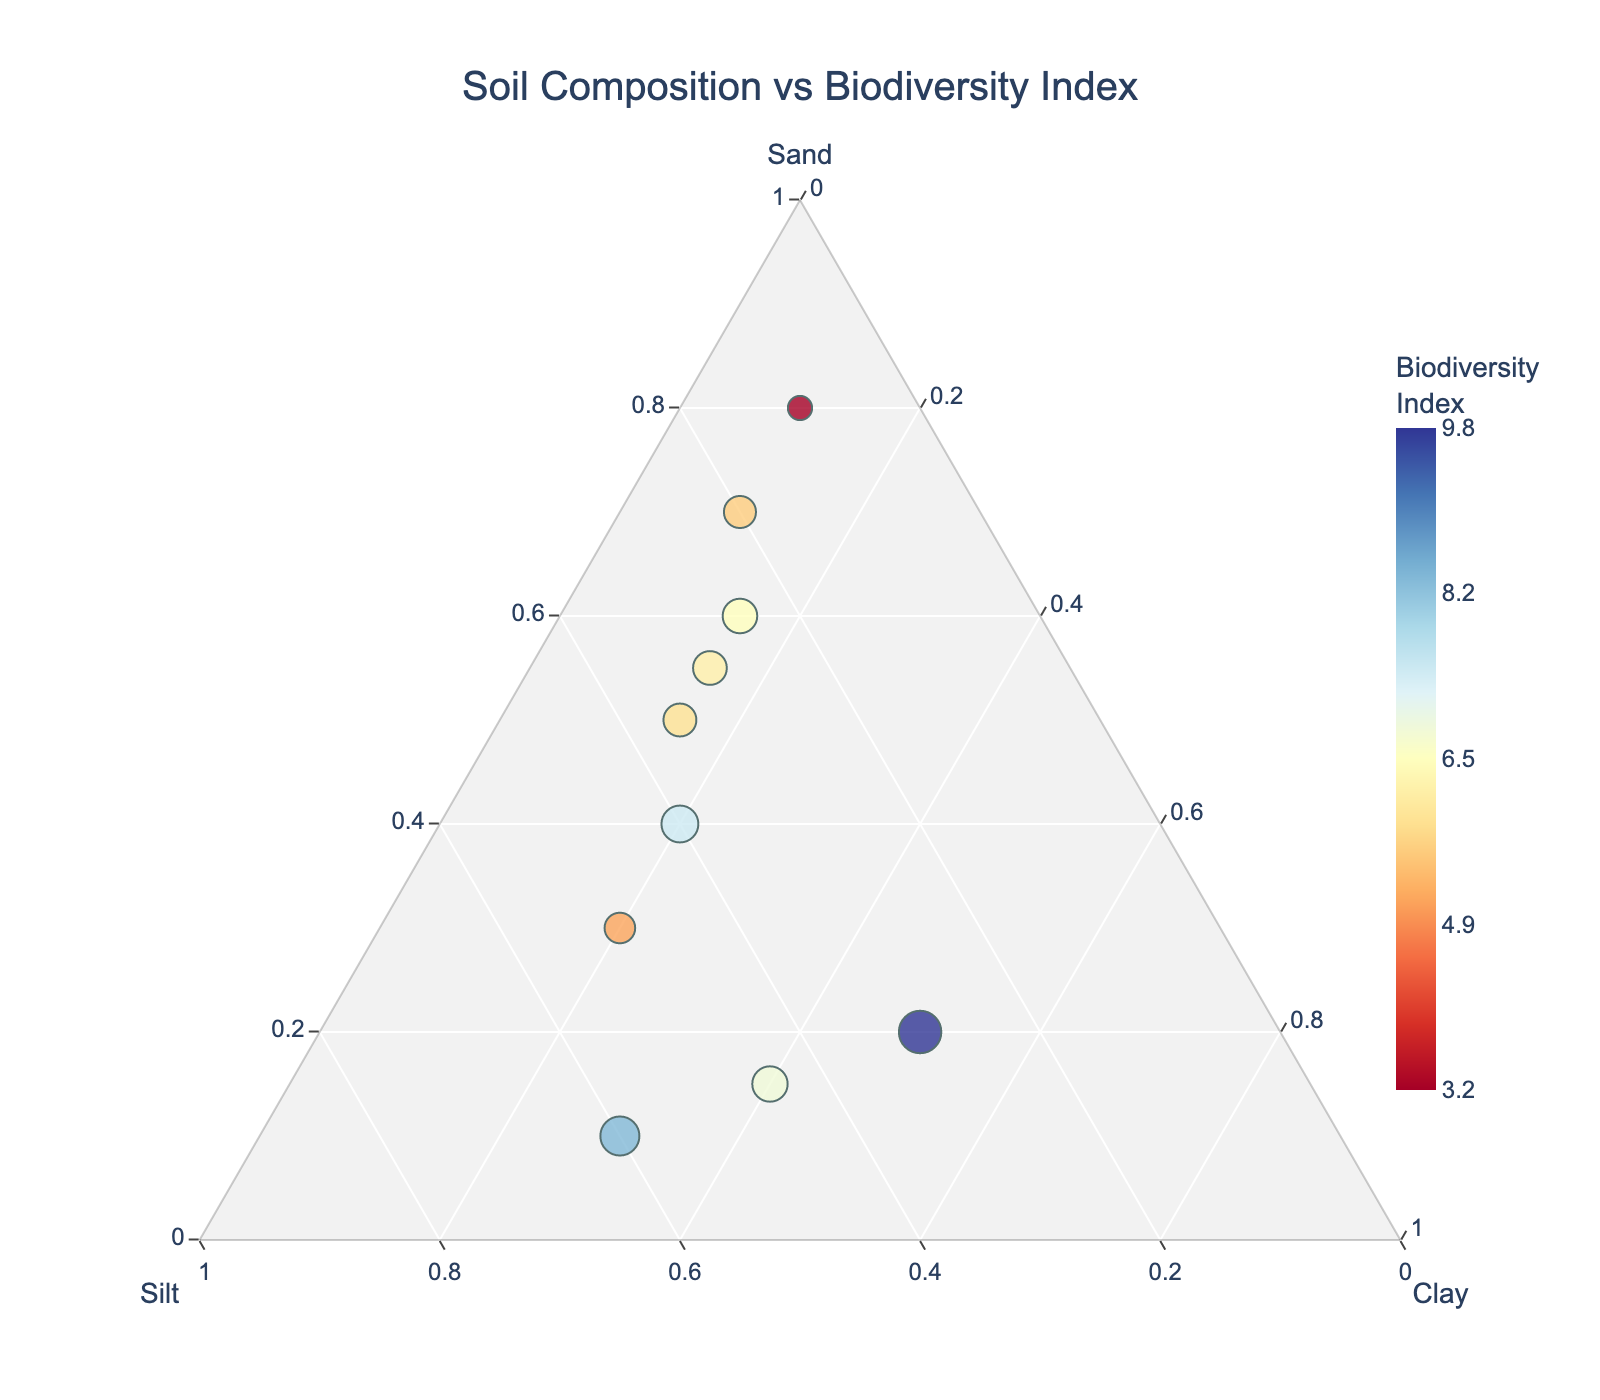What is the title of the plot? The title can be directly observed at the top of the plot. It summarizes the main purpose of the figure.
Answer: Soil Composition vs Biodiversity Index How many locations are represented in the plot? Each dot in the plot represents a location. By counting the dots, we can determine the number of locations.
Answer: 10 Which location has the highest Biodiversity Index? The size and color of the dots in the plot indicate the Biodiversity Index. The largest and most intensely colored dot corresponds to the highest Biodiversity Index.
Answer: Amazon Rainforest What is the soil composition of the Wetland Ecosystem in terms of sand, silt, and clay? Hovering over the dot labeled "Wetland Ecosystem" will display detailed information about its soil composition: percentages of sand, silt, and clay.
Answer: Sand: 10%, Silt: 60%, Clay: 30% Which location has a sand content greater than 50% and the lowest Biodiversity Index? Find the location where the sand content crosses the 50% threshold, and among those, identify the one with the smallest dot (lowest Biodiversity Index).
Answer: Sonoran Desert Which two locations have similar sand content but differ significantly in their Biodiversity Index? Compare the dots in terms of their position along the sand axis and check the differences in dot size and color for Biodiversity Index variations.
Answer: Tropical Savanna and Mediterranean Scrubland Among locations with a clay content of 20%, which one has the higher Biodiversity Index? Locate dots with a clay content of 20% (shared edge) and compare their Biodiversity Index as indicated by dot size and color.
Answer: Temperate Deciduous Forest What is the average silt content among all the locations? Sum the percentages of silt content for all locations and divide by the number of locations (10) to find the average silt content.
Answer: (30+25+10+40+35+45+50+30+20+60)/10 = 34.5% Compare Boreal Forest and Coastal Mangrove. Which one has a higher silt content, and what is the difference in their Biodiversity Indexes? Examine the silt positions of both locations and note their Biodiversity Indexes. Calculate the Biodiversity Index difference.
Answer: Coastal Mangrove, 1.7 (6.8 - 5.1) 